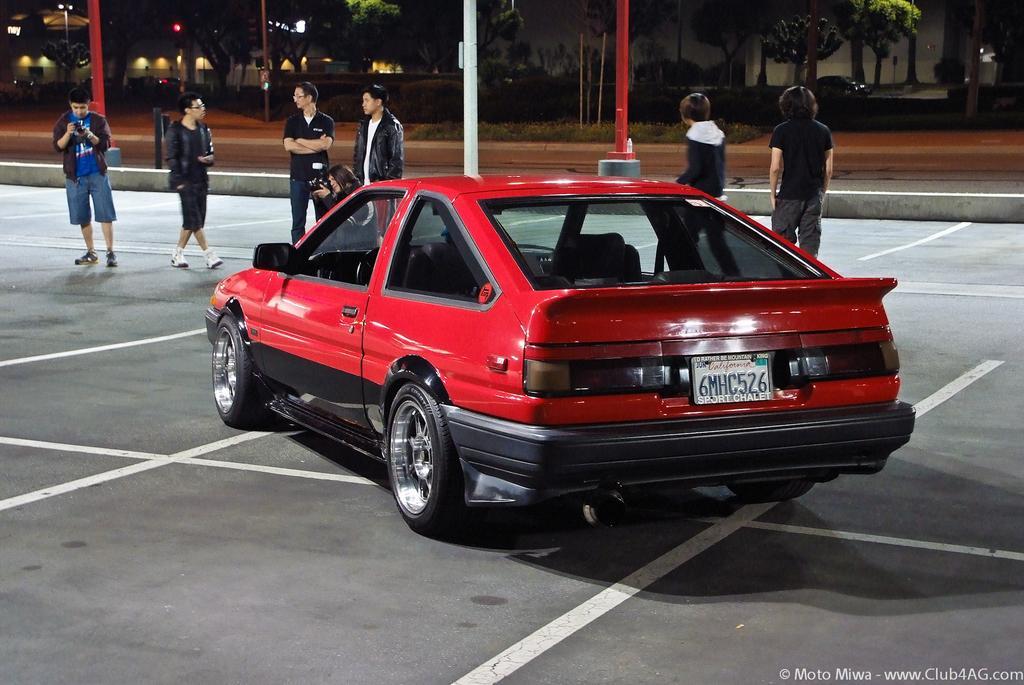Please provide a concise description of this image. This picture shows a red color car and we see few people standing and we see poles and few buildings and trees and we see another car on the side. 